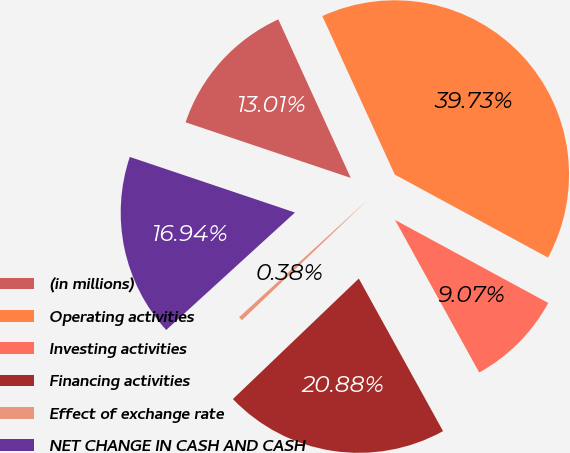Convert chart to OTSL. <chart><loc_0><loc_0><loc_500><loc_500><pie_chart><fcel>(in millions)<fcel>Operating activities<fcel>Investing activities<fcel>Financing activities<fcel>Effect of exchange rate<fcel>NET CHANGE IN CASH AND CASH<nl><fcel>13.01%<fcel>39.73%<fcel>9.07%<fcel>20.88%<fcel>0.38%<fcel>16.94%<nl></chart> 